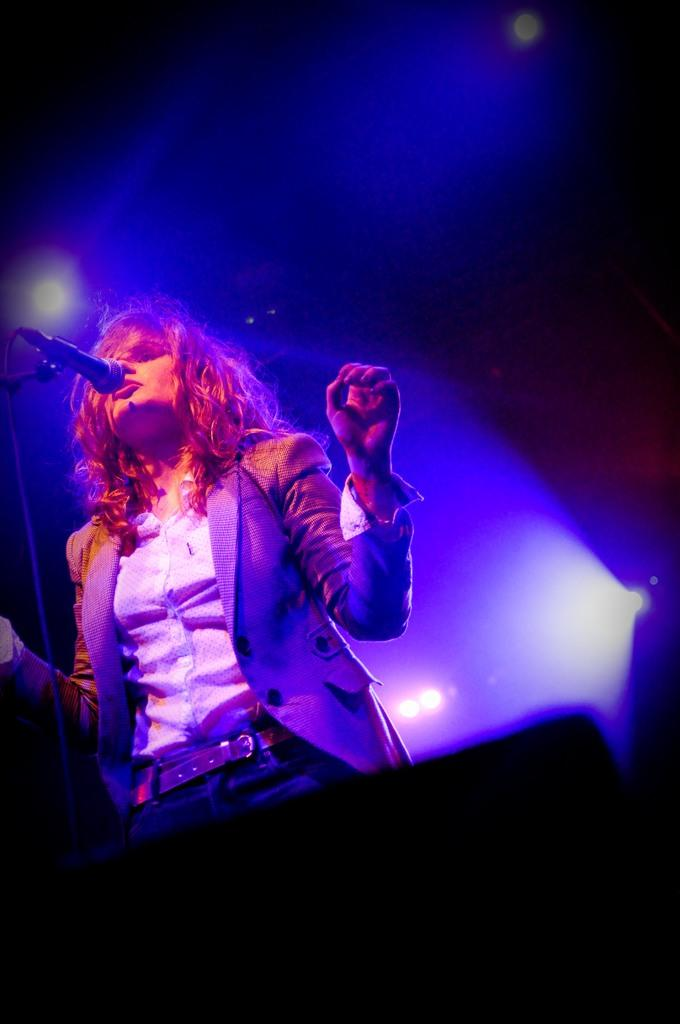Who is the main subject in the image? There is a woman in the image. What is the woman doing in the image? The woman is standing in the image. What object is in front of the woman? There is a microphone with a stand in front of the woman. What can be seen behind the woman in the image? There are lights visible behind the woman. What type of face cream is visible on the woman's face in the image? There is no face cream visible on the woman's face in the image. What order is the woman following while standing in the image? The image does not provide information about any specific order the woman is following. 